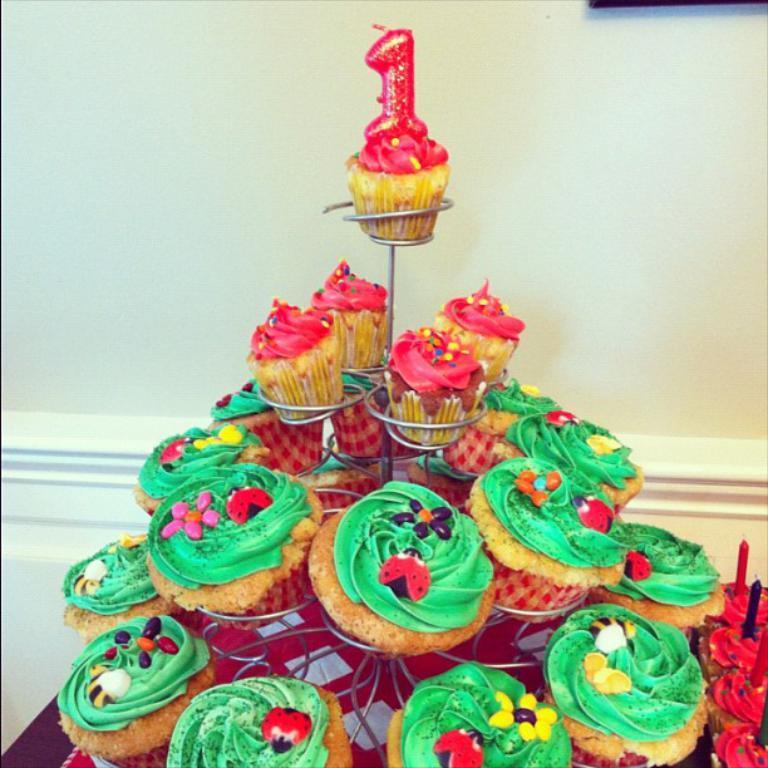How would you summarize this image in a sentence or two? In this picture I can see few muffins on the stand. I can see candles on the muffins and a wall in the background. 